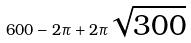Convert formula to latex. <formula><loc_0><loc_0><loc_500><loc_500>6 0 0 - 2 \pi + 2 \pi \sqrt { 3 0 0 }</formula> 